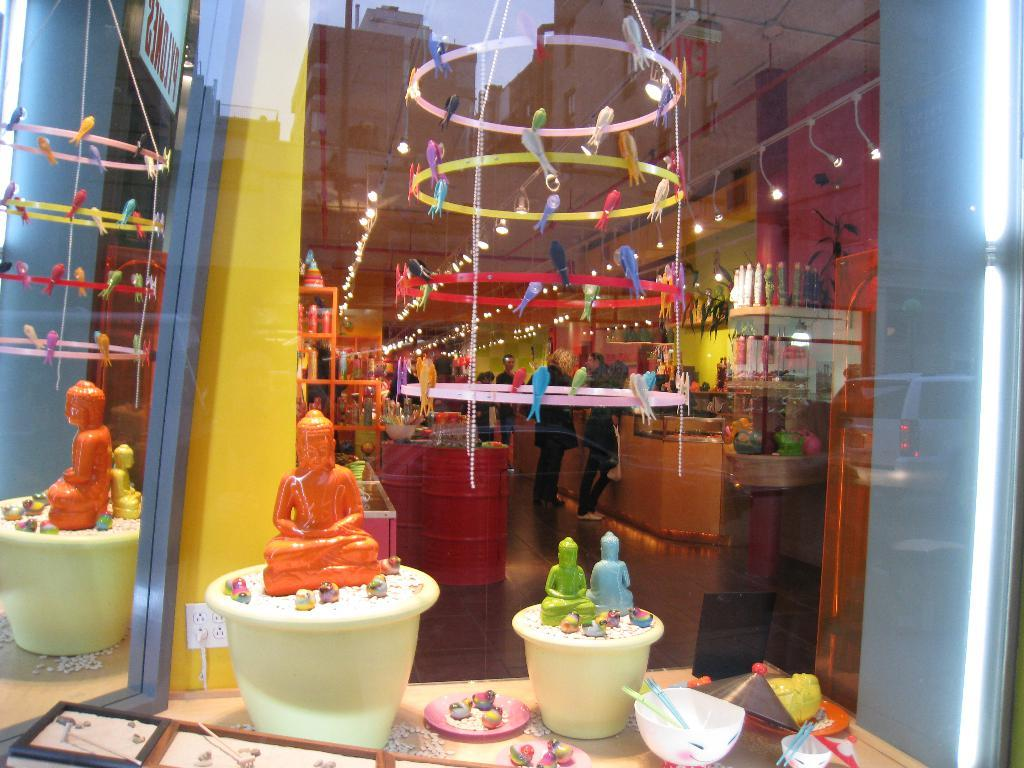What is placed on the flower pots in the image? There are toys placed on flower pots in the image. What can be seen in the background of the image? There are people and other objects in the background of the image. How many rays are visible in the image? There are no rays visible in the image. What type of crime is being committed in the image? There is no crime being committed in the image. 